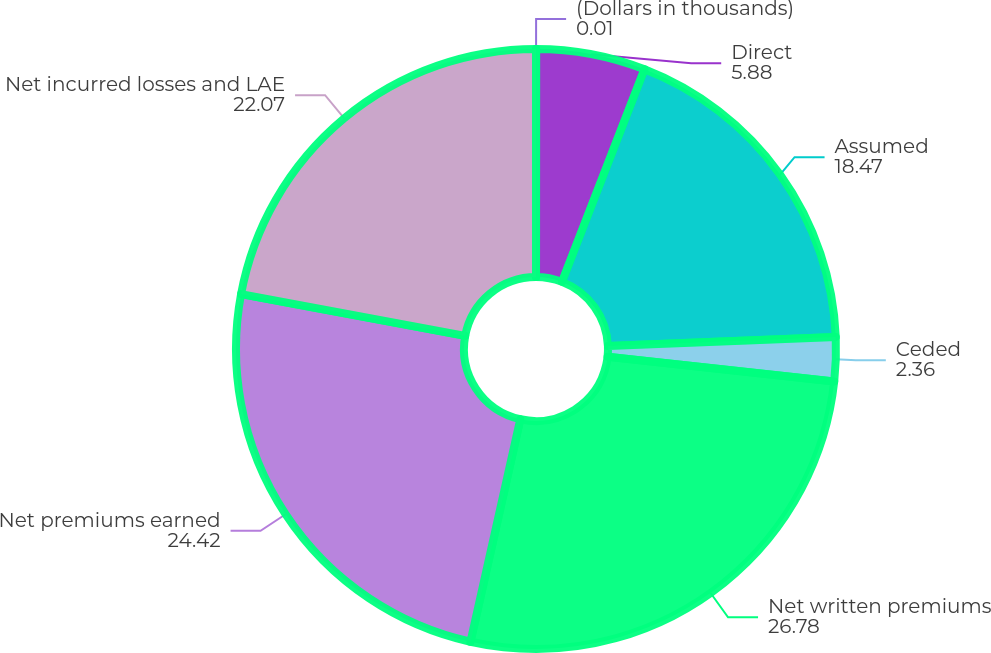Convert chart. <chart><loc_0><loc_0><loc_500><loc_500><pie_chart><fcel>(Dollars in thousands)<fcel>Direct<fcel>Assumed<fcel>Ceded<fcel>Net written premiums<fcel>Net premiums earned<fcel>Net incurred losses and LAE<nl><fcel>0.01%<fcel>5.88%<fcel>18.47%<fcel>2.36%<fcel>26.78%<fcel>24.42%<fcel>22.07%<nl></chart> 